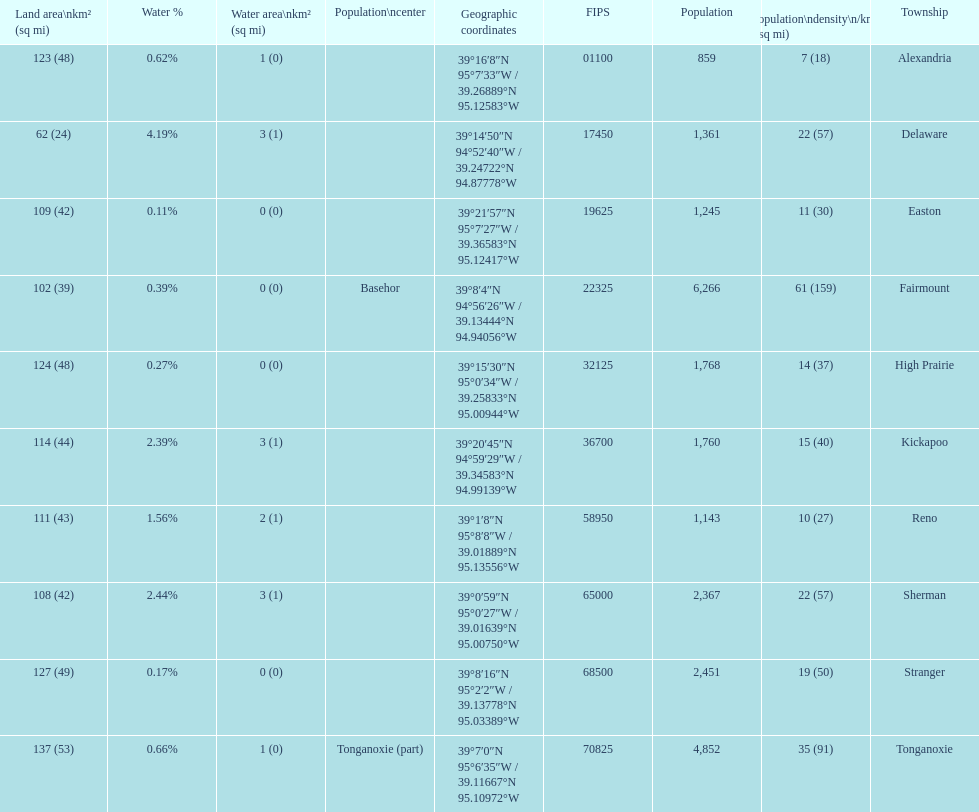What township has the most land area? Tonganoxie. 